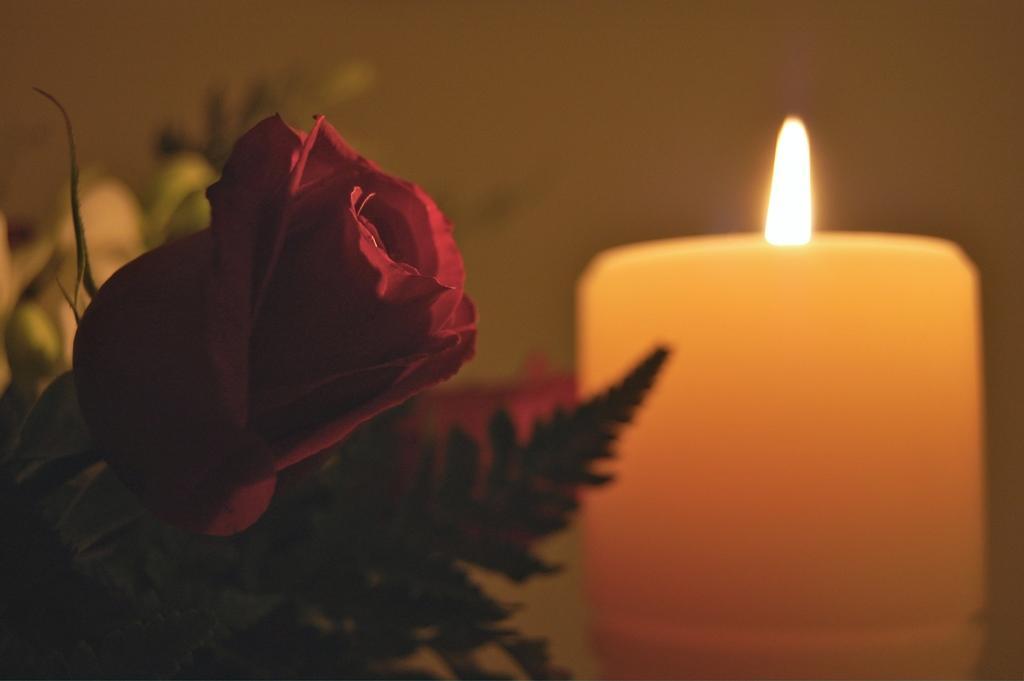In one or two sentences, can you explain what this image depicts? In this image on the left side we can see a flower and leaves. On the right side we can see a candle with flame. In the background the image is blur but we can see objects. 